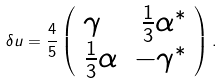<formula> <loc_0><loc_0><loc_500><loc_500>\delta u = \frac { 4 } { 5 } \left ( \begin{array} { l r } \gamma & \frac { 1 } { 3 } \alpha ^ { * } \\ \frac { 1 } { 3 } \alpha & - \gamma ^ { * } \end{array} \right ) .</formula> 